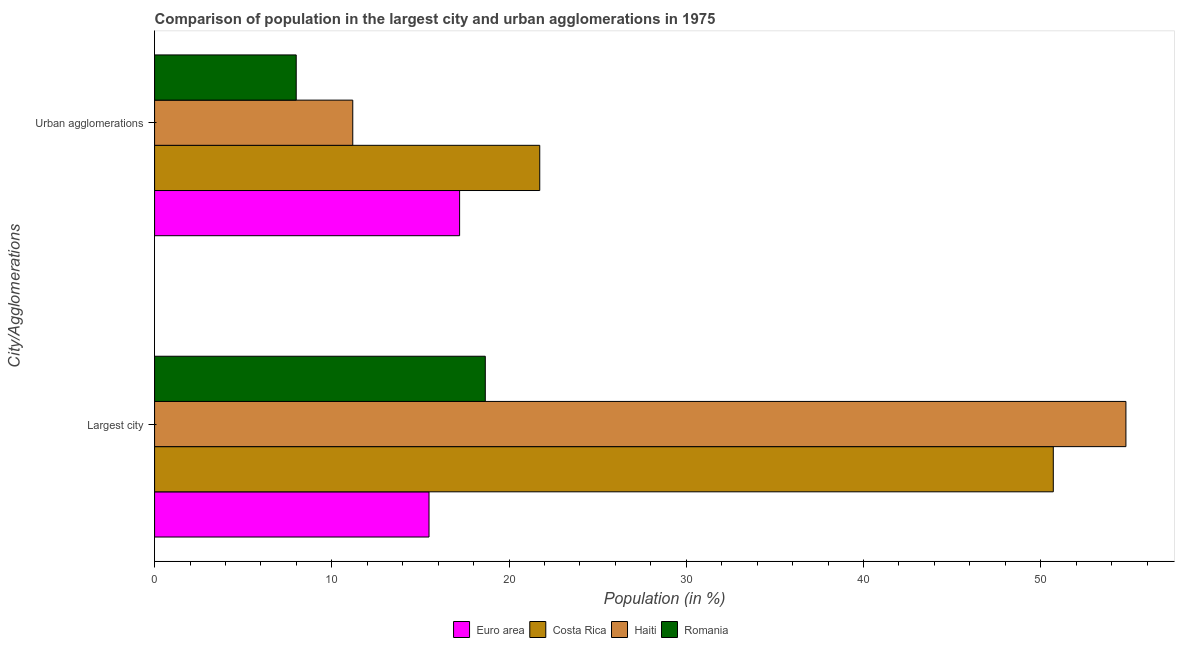How many groups of bars are there?
Provide a short and direct response. 2. How many bars are there on the 1st tick from the top?
Offer a very short reply. 4. What is the label of the 2nd group of bars from the top?
Offer a very short reply. Largest city. What is the population in the largest city in Costa Rica?
Give a very brief answer. 50.71. Across all countries, what is the maximum population in the largest city?
Keep it short and to the point. 54.8. Across all countries, what is the minimum population in urban agglomerations?
Provide a short and direct response. 7.99. In which country was the population in the largest city maximum?
Offer a terse response. Haiti. What is the total population in urban agglomerations in the graph?
Provide a short and direct response. 58.12. What is the difference between the population in the largest city in Costa Rica and that in Romania?
Provide a short and direct response. 32.05. What is the difference between the population in the largest city in Euro area and the population in urban agglomerations in Haiti?
Offer a very short reply. 4.3. What is the average population in urban agglomerations per country?
Offer a terse response. 14.53. What is the difference between the population in the largest city and population in urban agglomerations in Haiti?
Your response must be concise. 43.62. What is the ratio of the population in urban agglomerations in Costa Rica to that in Romania?
Your answer should be very brief. 2.72. In how many countries, is the population in urban agglomerations greater than the average population in urban agglomerations taken over all countries?
Provide a succinct answer. 2. How many bars are there?
Your response must be concise. 8. Are all the bars in the graph horizontal?
Your response must be concise. Yes. How many countries are there in the graph?
Make the answer very short. 4. What is the difference between two consecutive major ticks on the X-axis?
Your response must be concise. 10. Are the values on the major ticks of X-axis written in scientific E-notation?
Your response must be concise. No. Does the graph contain any zero values?
Your answer should be compact. No. Does the graph contain grids?
Ensure brevity in your answer.  No. How are the legend labels stacked?
Make the answer very short. Horizontal. What is the title of the graph?
Offer a terse response. Comparison of population in the largest city and urban agglomerations in 1975. What is the label or title of the X-axis?
Your answer should be very brief. Population (in %). What is the label or title of the Y-axis?
Provide a short and direct response. City/Agglomerations. What is the Population (in %) in Euro area in Largest city?
Give a very brief answer. 15.48. What is the Population (in %) in Costa Rica in Largest city?
Give a very brief answer. 50.71. What is the Population (in %) of Haiti in Largest city?
Offer a very short reply. 54.8. What is the Population (in %) in Romania in Largest city?
Provide a succinct answer. 18.66. What is the Population (in %) of Euro area in Urban agglomerations?
Offer a terse response. 17.21. What is the Population (in %) in Costa Rica in Urban agglomerations?
Provide a succinct answer. 21.73. What is the Population (in %) in Haiti in Urban agglomerations?
Your answer should be compact. 11.18. What is the Population (in %) in Romania in Urban agglomerations?
Make the answer very short. 7.99. Across all City/Agglomerations, what is the maximum Population (in %) of Euro area?
Your answer should be very brief. 17.21. Across all City/Agglomerations, what is the maximum Population (in %) of Costa Rica?
Keep it short and to the point. 50.71. Across all City/Agglomerations, what is the maximum Population (in %) of Haiti?
Your answer should be compact. 54.8. Across all City/Agglomerations, what is the maximum Population (in %) of Romania?
Offer a very short reply. 18.66. Across all City/Agglomerations, what is the minimum Population (in %) of Euro area?
Your answer should be very brief. 15.48. Across all City/Agglomerations, what is the minimum Population (in %) in Costa Rica?
Offer a terse response. 21.73. Across all City/Agglomerations, what is the minimum Population (in %) of Haiti?
Provide a short and direct response. 11.18. Across all City/Agglomerations, what is the minimum Population (in %) of Romania?
Give a very brief answer. 7.99. What is the total Population (in %) in Euro area in the graph?
Provide a short and direct response. 32.7. What is the total Population (in %) in Costa Rica in the graph?
Provide a succinct answer. 72.44. What is the total Population (in %) of Haiti in the graph?
Your answer should be compact. 65.99. What is the total Population (in %) of Romania in the graph?
Your answer should be very brief. 26.65. What is the difference between the Population (in %) in Euro area in Largest city and that in Urban agglomerations?
Offer a very short reply. -1.73. What is the difference between the Population (in %) in Costa Rica in Largest city and that in Urban agglomerations?
Your response must be concise. 28.97. What is the difference between the Population (in %) of Haiti in Largest city and that in Urban agglomerations?
Make the answer very short. 43.62. What is the difference between the Population (in %) in Romania in Largest city and that in Urban agglomerations?
Keep it short and to the point. 10.67. What is the difference between the Population (in %) of Euro area in Largest city and the Population (in %) of Costa Rica in Urban agglomerations?
Provide a succinct answer. -6.25. What is the difference between the Population (in %) of Euro area in Largest city and the Population (in %) of Haiti in Urban agglomerations?
Make the answer very short. 4.3. What is the difference between the Population (in %) of Euro area in Largest city and the Population (in %) of Romania in Urban agglomerations?
Your response must be concise. 7.49. What is the difference between the Population (in %) of Costa Rica in Largest city and the Population (in %) of Haiti in Urban agglomerations?
Keep it short and to the point. 39.52. What is the difference between the Population (in %) of Costa Rica in Largest city and the Population (in %) of Romania in Urban agglomerations?
Keep it short and to the point. 42.71. What is the difference between the Population (in %) of Haiti in Largest city and the Population (in %) of Romania in Urban agglomerations?
Your answer should be very brief. 46.81. What is the average Population (in %) in Euro area per City/Agglomerations?
Your answer should be very brief. 16.35. What is the average Population (in %) of Costa Rica per City/Agglomerations?
Offer a terse response. 36.22. What is the average Population (in %) of Haiti per City/Agglomerations?
Give a very brief answer. 32.99. What is the average Population (in %) in Romania per City/Agglomerations?
Your answer should be compact. 13.33. What is the difference between the Population (in %) of Euro area and Population (in %) of Costa Rica in Largest city?
Keep it short and to the point. -35.22. What is the difference between the Population (in %) in Euro area and Population (in %) in Haiti in Largest city?
Provide a succinct answer. -39.32. What is the difference between the Population (in %) in Euro area and Population (in %) in Romania in Largest city?
Provide a succinct answer. -3.17. What is the difference between the Population (in %) of Costa Rica and Population (in %) of Haiti in Largest city?
Provide a short and direct response. -4.1. What is the difference between the Population (in %) of Costa Rica and Population (in %) of Romania in Largest city?
Keep it short and to the point. 32.05. What is the difference between the Population (in %) of Haiti and Population (in %) of Romania in Largest city?
Your answer should be compact. 36.15. What is the difference between the Population (in %) of Euro area and Population (in %) of Costa Rica in Urban agglomerations?
Ensure brevity in your answer.  -4.52. What is the difference between the Population (in %) in Euro area and Population (in %) in Haiti in Urban agglomerations?
Keep it short and to the point. 6.03. What is the difference between the Population (in %) in Euro area and Population (in %) in Romania in Urban agglomerations?
Provide a short and direct response. 9.22. What is the difference between the Population (in %) of Costa Rica and Population (in %) of Haiti in Urban agglomerations?
Give a very brief answer. 10.55. What is the difference between the Population (in %) of Costa Rica and Population (in %) of Romania in Urban agglomerations?
Provide a succinct answer. 13.74. What is the difference between the Population (in %) in Haiti and Population (in %) in Romania in Urban agglomerations?
Your response must be concise. 3.19. What is the ratio of the Population (in %) of Euro area in Largest city to that in Urban agglomerations?
Offer a terse response. 0.9. What is the ratio of the Population (in %) in Costa Rica in Largest city to that in Urban agglomerations?
Offer a terse response. 2.33. What is the ratio of the Population (in %) in Haiti in Largest city to that in Urban agglomerations?
Your answer should be very brief. 4.9. What is the ratio of the Population (in %) in Romania in Largest city to that in Urban agglomerations?
Offer a terse response. 2.33. What is the difference between the highest and the second highest Population (in %) in Euro area?
Offer a terse response. 1.73. What is the difference between the highest and the second highest Population (in %) of Costa Rica?
Your answer should be compact. 28.97. What is the difference between the highest and the second highest Population (in %) in Haiti?
Offer a terse response. 43.62. What is the difference between the highest and the second highest Population (in %) of Romania?
Offer a very short reply. 10.67. What is the difference between the highest and the lowest Population (in %) in Euro area?
Provide a short and direct response. 1.73. What is the difference between the highest and the lowest Population (in %) in Costa Rica?
Offer a terse response. 28.97. What is the difference between the highest and the lowest Population (in %) in Haiti?
Offer a terse response. 43.62. What is the difference between the highest and the lowest Population (in %) in Romania?
Make the answer very short. 10.67. 